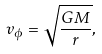Convert formula to latex. <formula><loc_0><loc_0><loc_500><loc_500>v _ { \phi } = \sqrt { \frac { G M } { r } } ,</formula> 